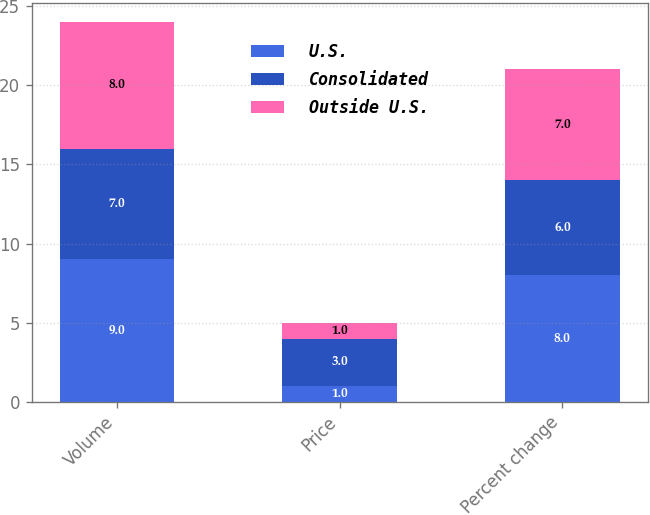Convert chart. <chart><loc_0><loc_0><loc_500><loc_500><stacked_bar_chart><ecel><fcel>Volume<fcel>Price<fcel>Percent change<nl><fcel>U.S.<fcel>9<fcel>1<fcel>8<nl><fcel>Consolidated<fcel>7<fcel>3<fcel>6<nl><fcel>Outside U.S.<fcel>8<fcel>1<fcel>7<nl></chart> 